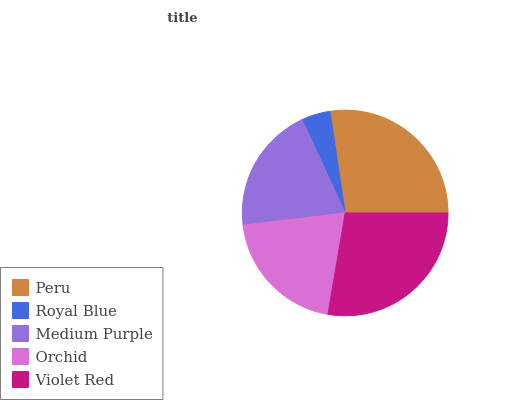Is Royal Blue the minimum?
Answer yes or no. Yes. Is Violet Red the maximum?
Answer yes or no. Yes. Is Medium Purple the minimum?
Answer yes or no. No. Is Medium Purple the maximum?
Answer yes or no. No. Is Medium Purple greater than Royal Blue?
Answer yes or no. Yes. Is Royal Blue less than Medium Purple?
Answer yes or no. Yes. Is Royal Blue greater than Medium Purple?
Answer yes or no. No. Is Medium Purple less than Royal Blue?
Answer yes or no. No. Is Orchid the high median?
Answer yes or no. Yes. Is Orchid the low median?
Answer yes or no. Yes. Is Peru the high median?
Answer yes or no. No. Is Royal Blue the low median?
Answer yes or no. No. 